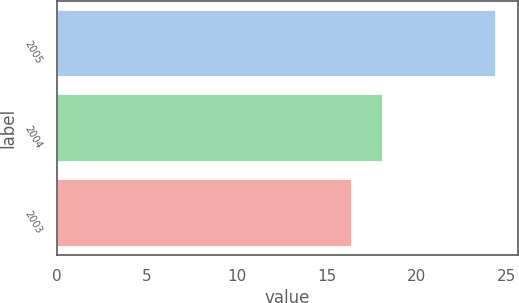Convert chart to OTSL. <chart><loc_0><loc_0><loc_500><loc_500><bar_chart><fcel>2005<fcel>2004<fcel>2003<nl><fcel>24.4<fcel>18.1<fcel>16.4<nl></chart> 